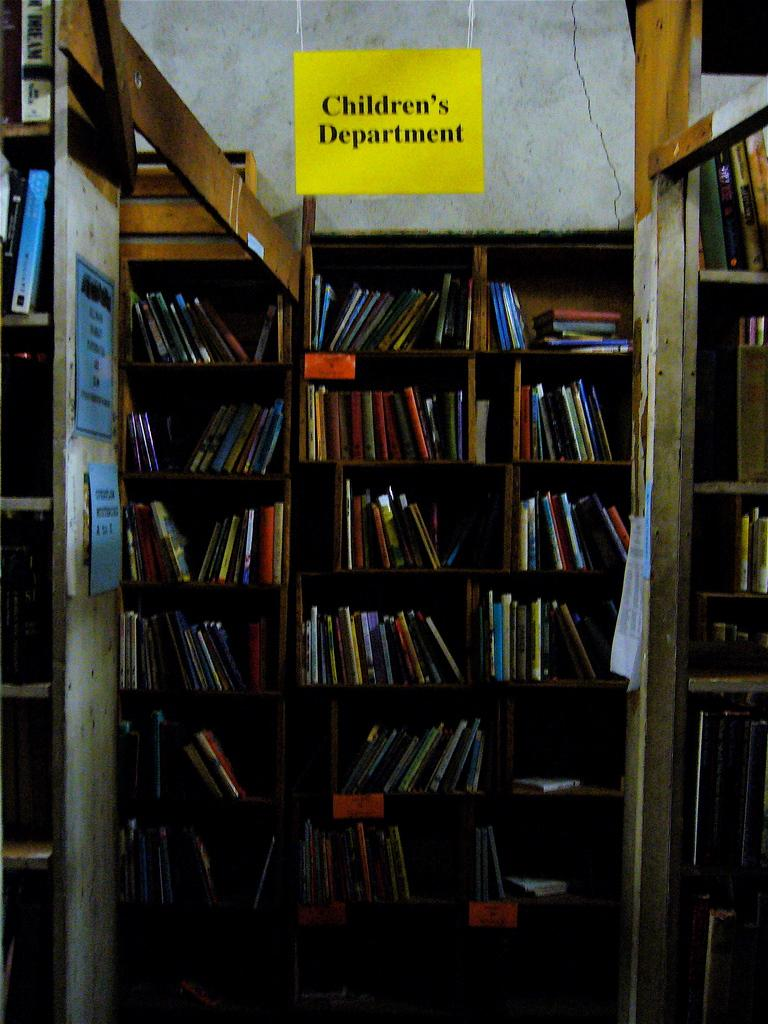<image>
Render a clear and concise summary of the photo. The children's department of a book store or library. 